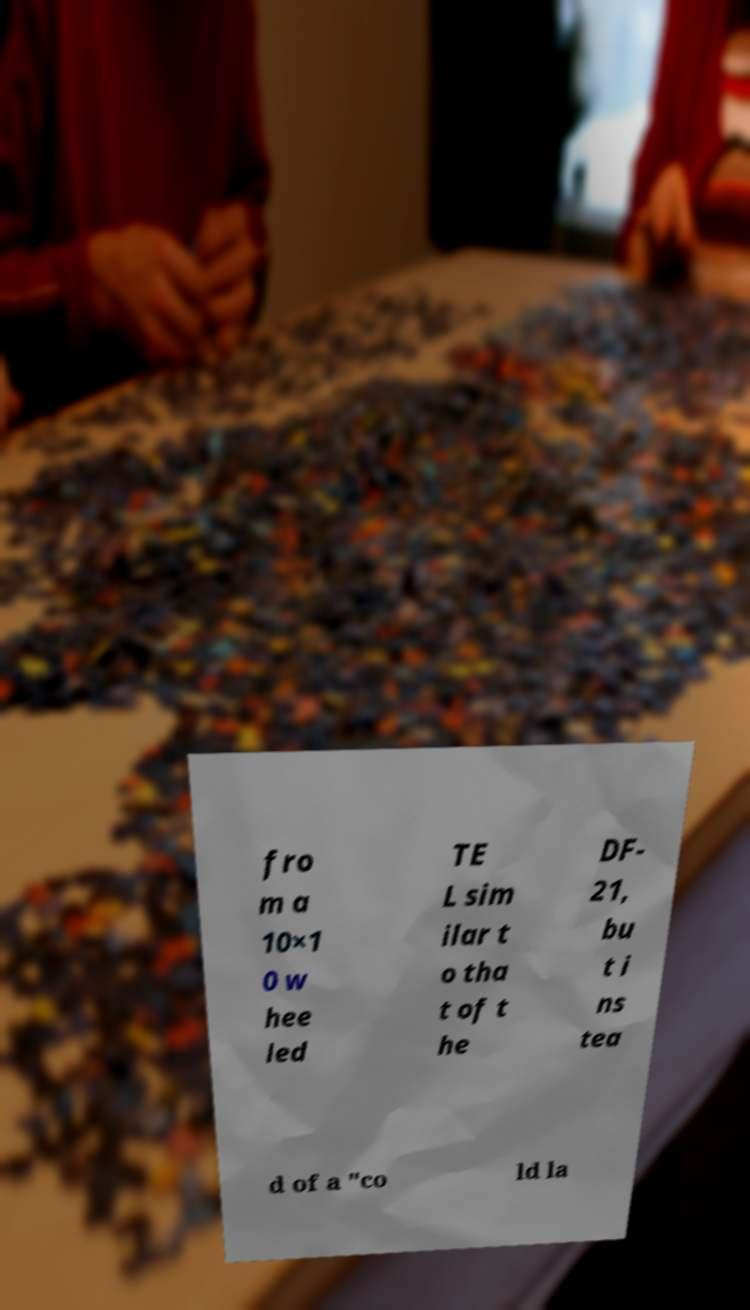I need the written content from this picture converted into text. Can you do that? fro m a 10×1 0 w hee led TE L sim ilar t o tha t of t he DF- 21, bu t i ns tea d of a "co ld la 